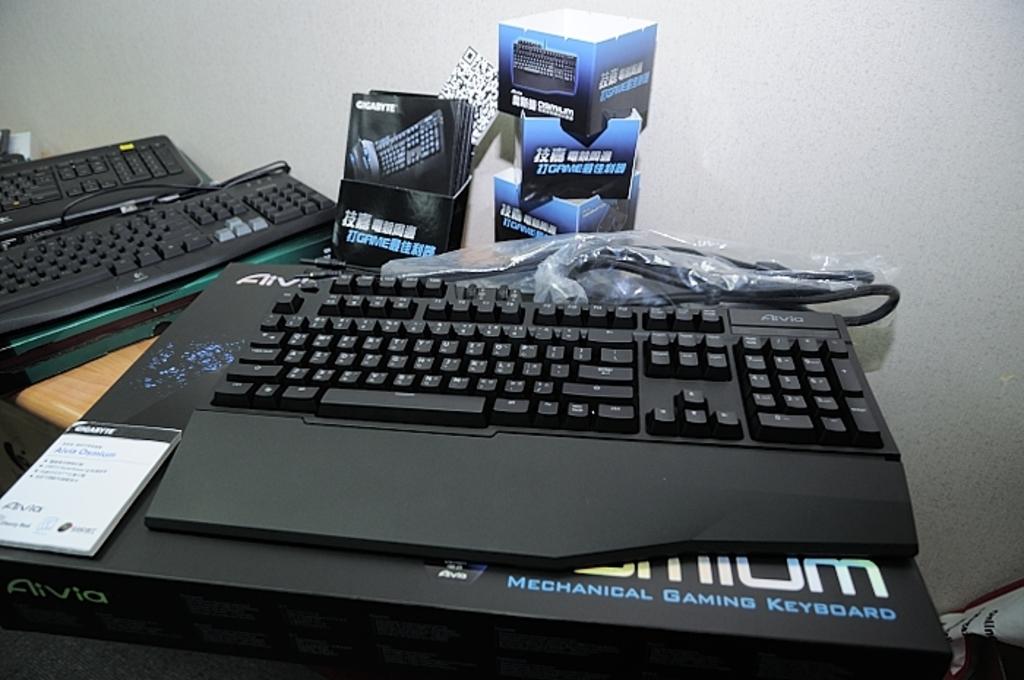What type of keyboard is this?
Provide a short and direct response. Aivia. Is this keyboard used for gaming?
Your answer should be compact. Yes. 